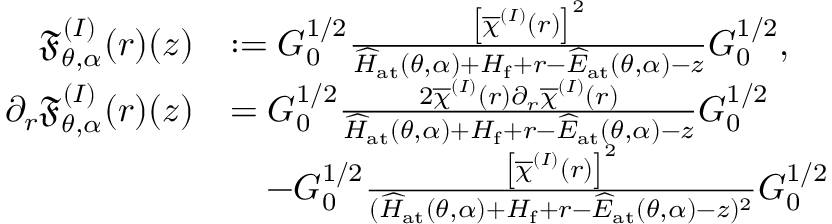Convert formula to latex. <formula><loc_0><loc_0><loc_500><loc_500>\begin{array} { r l } { \mathfrak { F } _ { \theta , \alpha } ^ { ( I ) } ( r ) ( z ) } & { \colon = G _ { 0 } ^ { 1 / 2 } \frac { \left [ \overline { \chi } ^ { ( I ) } ( r ) \right ] ^ { 2 } } { \widehat { H } _ { a t } ( \theta , \alpha ) + H _ { f } + r - \widehat { E } _ { a t } ( \theta , \alpha ) - z } G _ { 0 } ^ { 1 / 2 } , } \\ { \partial _ { r } \mathfrak { F } _ { \theta , \alpha } ^ { ( I ) } ( r ) ( z ) } & { = G _ { 0 } ^ { 1 / 2 } \frac { 2 \overline { \chi } ^ { ( I ) } ( r ) \partial _ { r } \overline { \chi } ^ { ( I ) } ( r ) } { \widehat { H } _ { a t } ( \theta , \alpha ) + H _ { f } + r - \widehat { E } _ { a t } ( \theta , \alpha ) - z } G _ { 0 } ^ { 1 / 2 } } \\ & { \quad - G _ { 0 } ^ { 1 / 2 } \frac { \left [ \overline { \chi } ^ { ( I ) } ( r ) \right ] ^ { 2 } } { ( \widehat { H } _ { a t } ( \theta , \alpha ) + H _ { f } + r - \widehat { E } _ { a t } ( \theta , \alpha ) - z ) ^ { 2 } } G _ { 0 } ^ { 1 / 2 } } \end{array}</formula> 